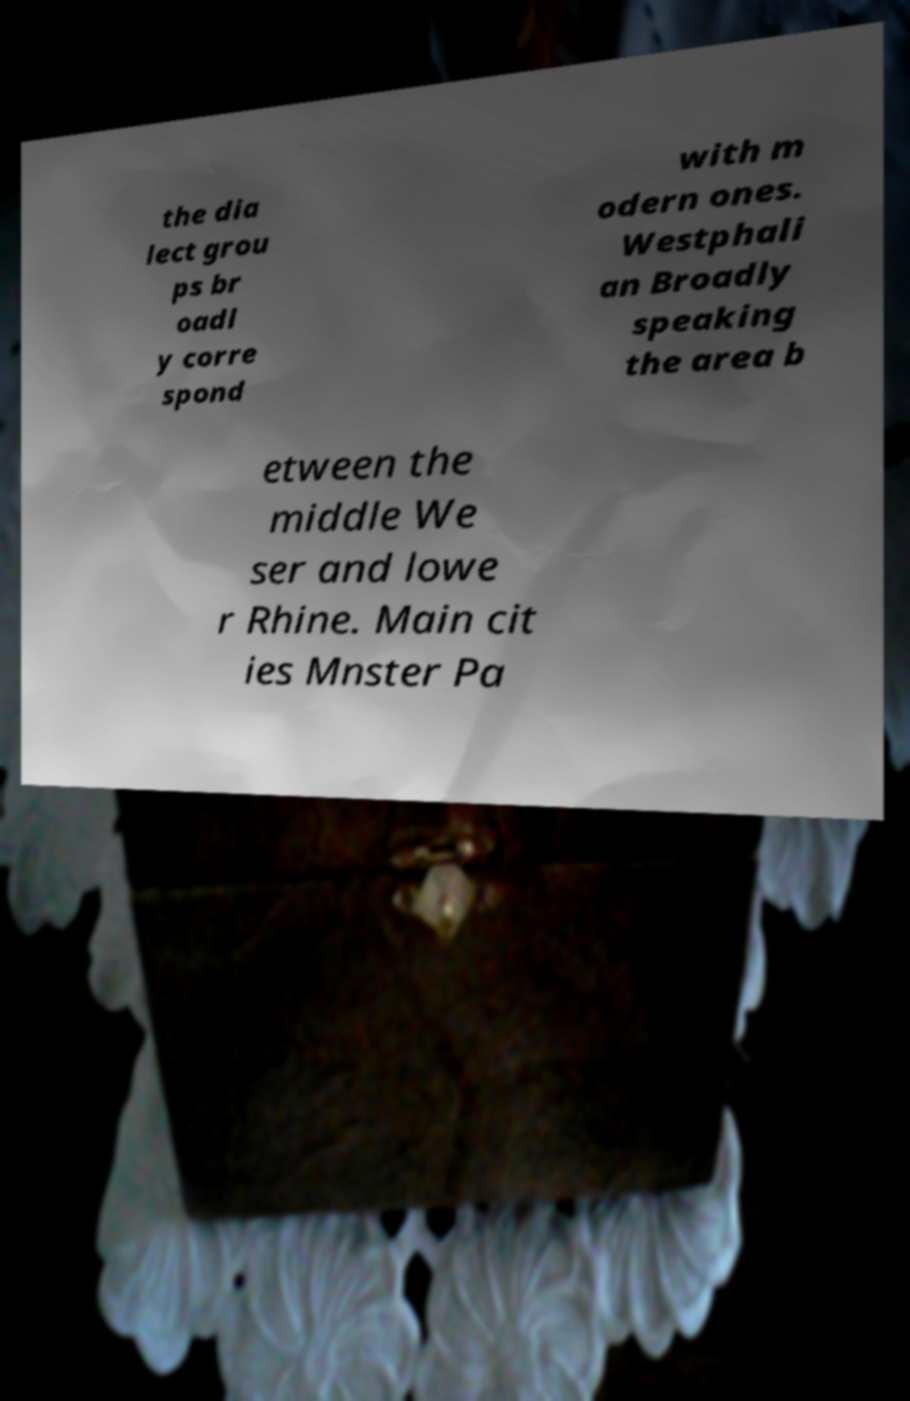For documentation purposes, I need the text within this image transcribed. Could you provide that? the dia lect grou ps br oadl y corre spond with m odern ones. Westphali an Broadly speaking the area b etween the middle We ser and lowe r Rhine. Main cit ies Mnster Pa 